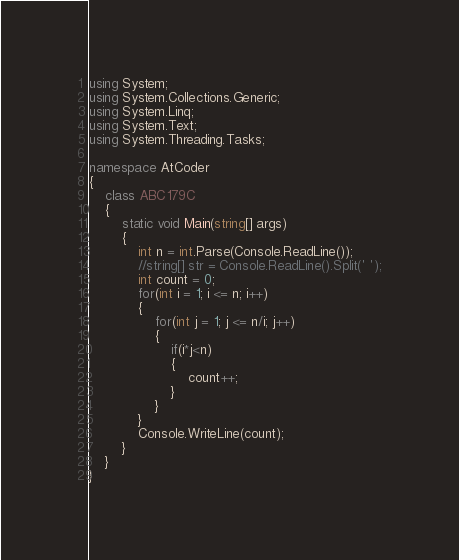Convert code to text. <code><loc_0><loc_0><loc_500><loc_500><_C#_>using System;
using System.Collections.Generic;
using System.Linq;
using System.Text;
using System.Threading.Tasks;
 
namespace AtCoder
{
    class ABC179C
    {
        static void Main(string[] args)
        {
            int n = int.Parse(Console.ReadLine());
            //string[] str = Console.ReadLine().Split(' ');
            int count = 0;
            for(int i = 1; i <= n; i++)
            {
                for(int j = 1; j <= n/i; j++)
                {
                    if(i*j<n)
                    {
                        count++;
                    }
                }
            }
            Console.WriteLine(count);
        }
    }
}</code> 